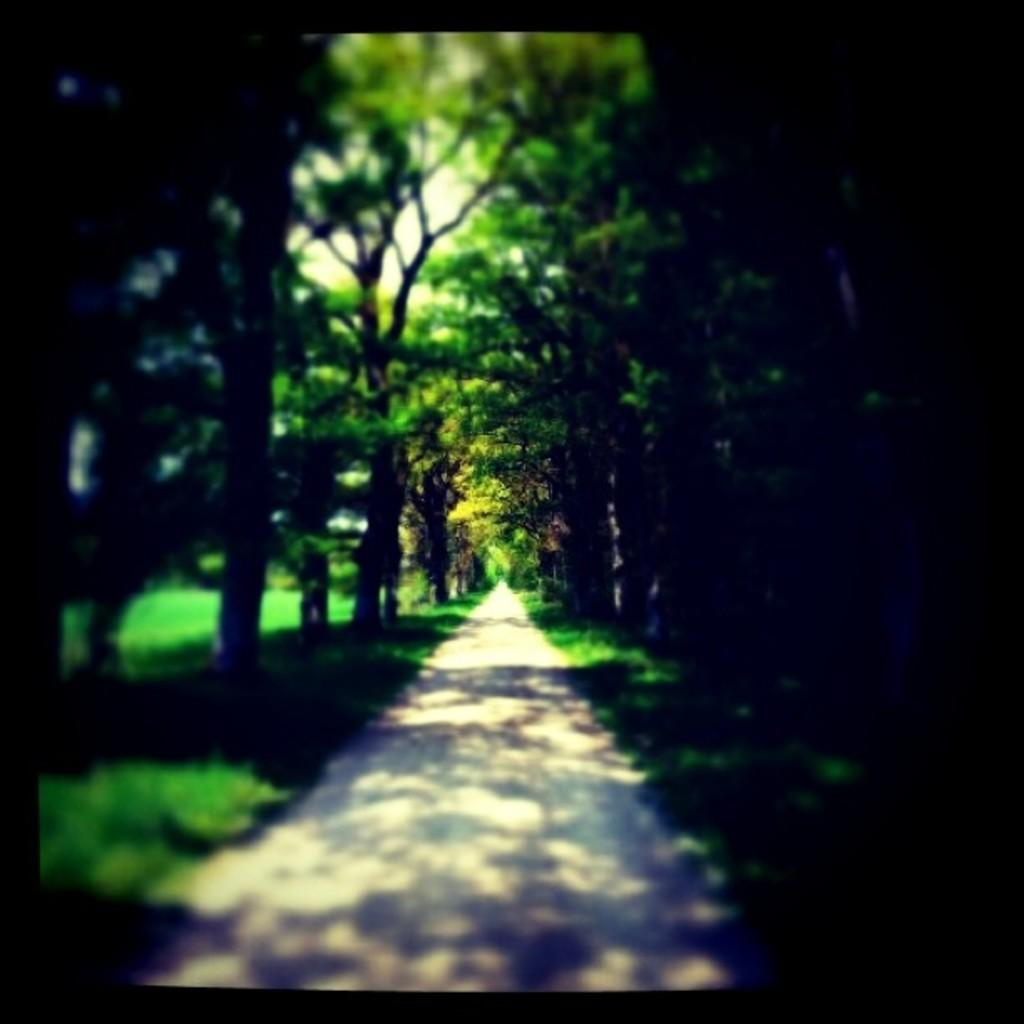What is the main feature of the image? There is a road in the image. Are there any other elements near the road? Yes, there are many trees near the road. What can be seen in the background of the image? The sky is visible in the background of the image. How many jellyfish can be seen swimming in the road in the image? There are no jellyfish present in the image, as it features a road with trees and a visible sky. 